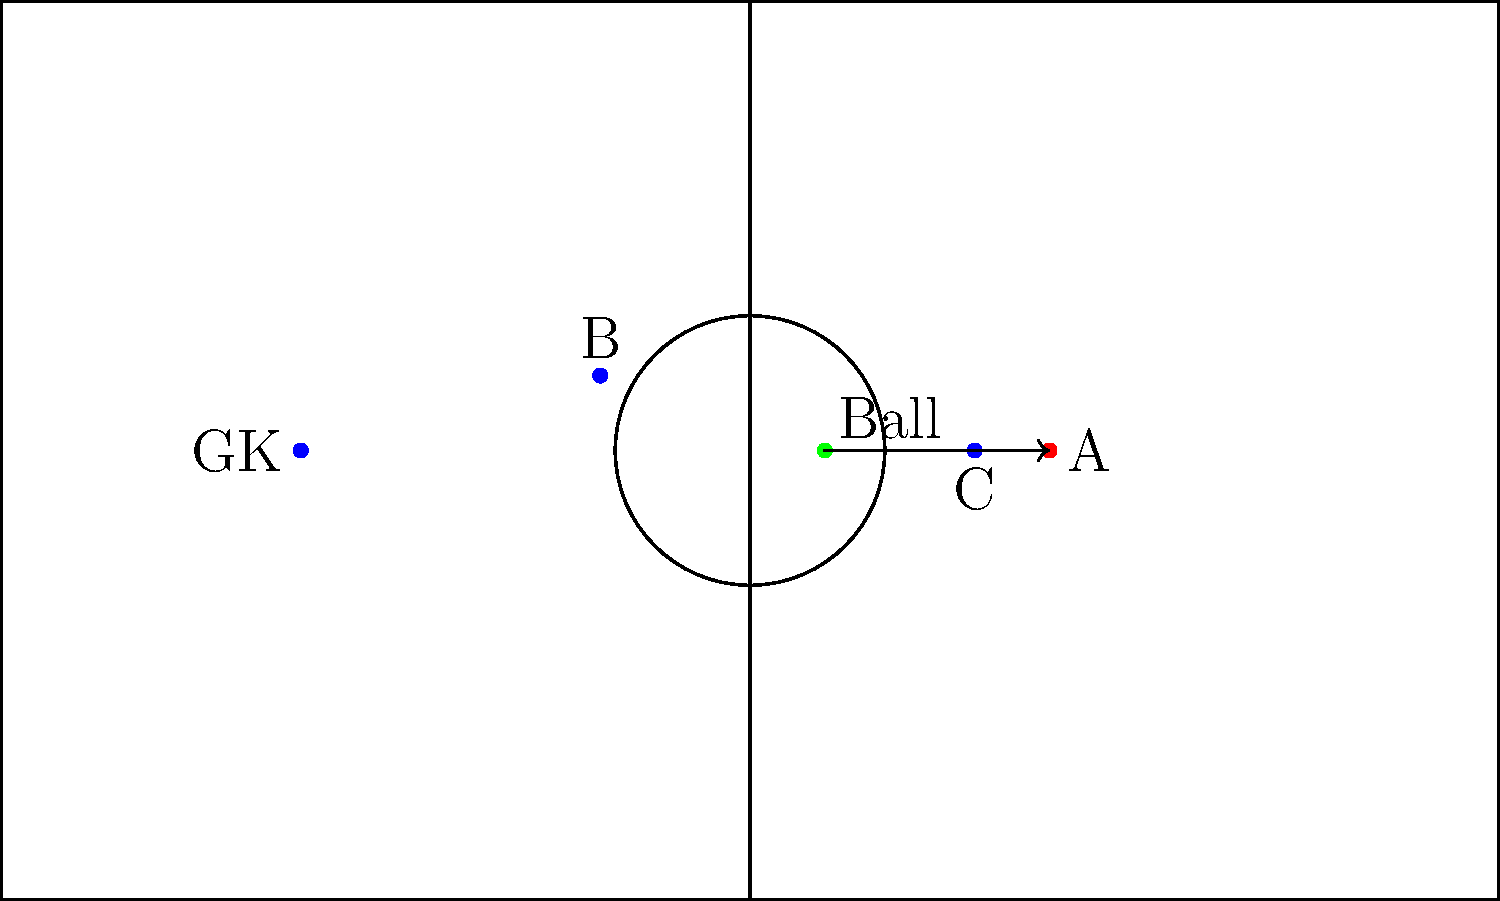In the diagram above, player A (red) is about to receive a forward pass from a teammate. Is player A in an offside position when the ball is played? Why or why not? To determine if player A is in an offside position, we need to follow these steps:

1. Identify the moment the ball is played: This is when the pass is made from the position of the ball (green dot).

2. Check the position of player A relative to the second-last opponent:
   - The goalkeeper (GK) is the last opponent.
   - Player C is the second-last opponent.

3. Compare player A's position to player C:
   - Player A is clearly ahead of player C when the ball is played.

4. Check if player A is in his own half:
   - The center line is at $x = 0$.
   - Player A is at $x = 20$, which is in the opponent's half.

5. Verify if player A is closer to the opponent's goal line than the ball:
   - The ball is at $x = 5$.
   - Player A is at $x = 20$, which is closer to the opponent's goal line.

6. Consider the offside rule exceptions:
   - This is not a goal kick, throw-in, or corner kick scenario.

Given that player A is in the opponent's half, ahead of the second-last opponent (C), and closer to the goal line than the ball when the pass is made, player A is in an offside position.

However, being in an offside position is not an offense by itself. An offside offense occurs only if player A becomes involved in active play by touching the ball or interfering with an opponent after the ball is played by a teammate.
Answer: Yes, player A is in an offside position. 